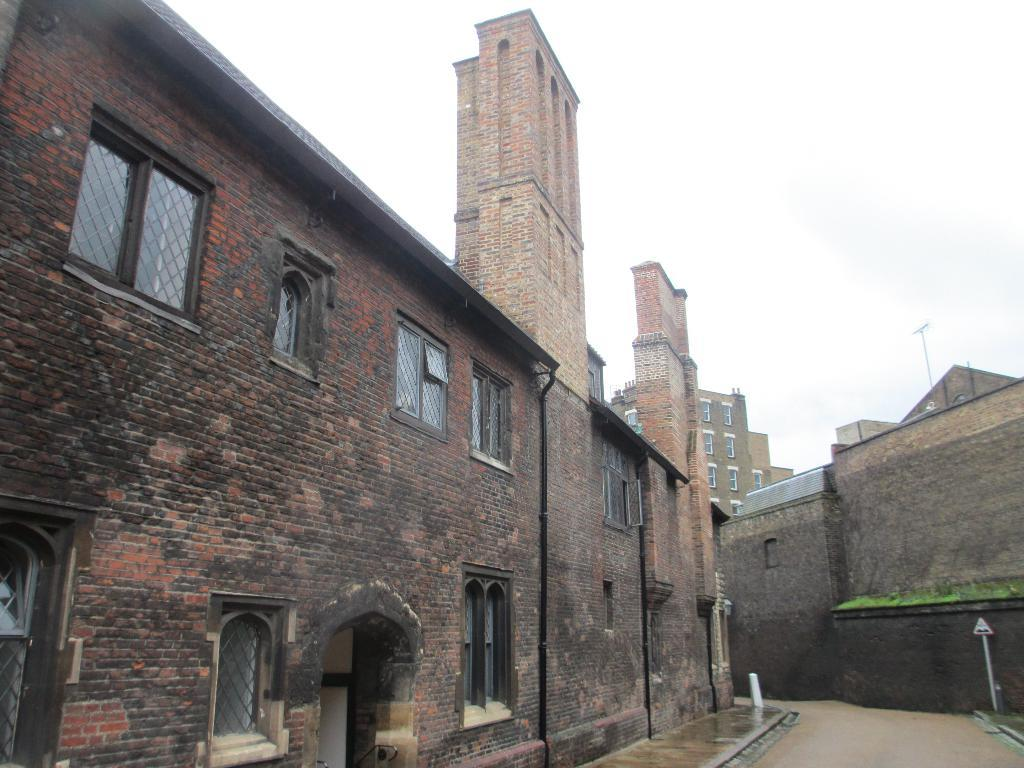What type of structures are visible in the image? There are buildings with windows in the image. What can be seen on the right side of the buildings? There is a pole with a signboard on the right side of the buildings. What is visible behind the buildings? The sky is visible behind the buildings. What subject is the teacher teaching in the image? There is no teacher or teaching activity present in the image. 